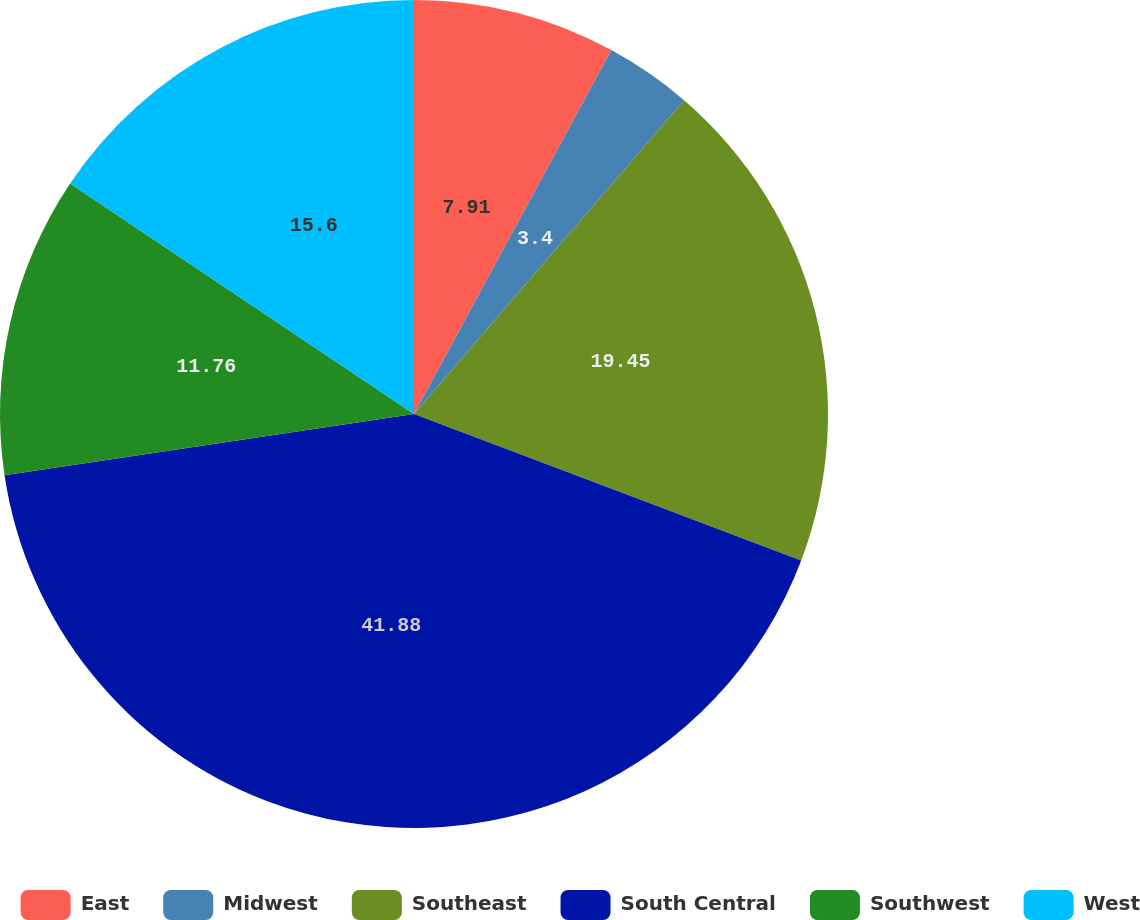<chart> <loc_0><loc_0><loc_500><loc_500><pie_chart><fcel>East<fcel>Midwest<fcel>Southeast<fcel>South Central<fcel>Southwest<fcel>West<nl><fcel>7.91%<fcel>3.4%<fcel>19.45%<fcel>41.88%<fcel>11.76%<fcel>15.6%<nl></chart> 